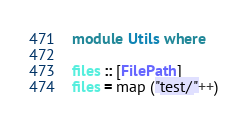<code> <loc_0><loc_0><loc_500><loc_500><_Haskell_>module Utils where

files :: [FilePath]
files = map ("test/"++)</code> 